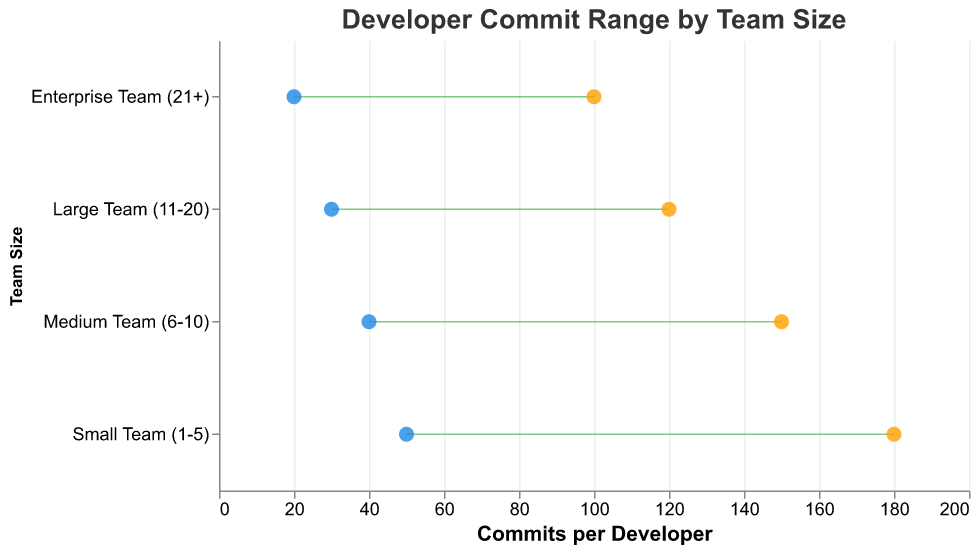What's the title of the plot? The title of the plot is located at the top of the figure and is meant to provide a brief description of the figure's content. It is "Developer Commit Range by Team Size."
Answer: Developer Commit Range by Team Size Which team size has the highest maximum commits per developer? By examining the points representing the maximum commits per developer, the highest value is at 180 commits, which corresponds to the "Small Team (1-5)" category.
Answer: Small Team (1-5) What is the range of commits for the Medium Team (6-10)? The range is calculated by subtracting the minimum commits from the maximum commits for the Medium Team (6-10). Here, the maximum commits are 150, and the minimum commits are 40. So, 150 - 40 = 110.
Answer: 110 Compare the minimum commits per developer for Small and Enterprise Teams. Which is higher? By comparing the minimum commits per developer, the Small Team has 50 commits while the Enterprise Team has 20 commits. Thus, the Small Team has higher minimum commits per developer.
Answer: Small Team (1-5) What is the average maximum commits per developer across all team sizes? Summing the maximum commits for all team sizes: 180 (Small) + 150 (Medium) + 120 (Large) + 100 (Enterprise) = 550. Dividing by the number of team sizes, which is 4: 550 / 4 = 137.5 commits.
Answer: 137.5 Which team size has the smallest range of commits per developer? The range is calculated by subtracting the minimum commits from the maximum commits for each team. The ranges are: Small (130), Medium (110), Large (90), and Enterprise (80). The Enterprise Team has the smallest range.
Answer: Enterprise Team (21+) Are the ranges of commits per developer increasing or decreasing with team size? By examining the ranges: Small (130), Medium (110), Large (90), and Enterprise (80), it is evident that the range of commits per developer decreases as team size increases.
Answer: Decreasing What's the approximate difference between the maximum commits for Small and Large teams? By comparing the maximum commits, Small Team has 180 commits and Large Team has 120 commits. The difference is 180 - 120 = 60 commits.
Answer: 60 If a developer is on a Medium Team, how many more commits should they make to reach the maximum compared to the minimum? For Medium Team, subtract the minimum commits (40) from the maximum commits (150): 150 - 40 = 110.
Answer: 110 Which team size shows the greatest variability in the number of commits per developer? Variability can be assessed as the range of commits for each team size. The ranges are: Small (130), Medium (110), Large (90), and Enterprise (80). The Small Team has the greatest variability.
Answer: Small Team (1-5) 